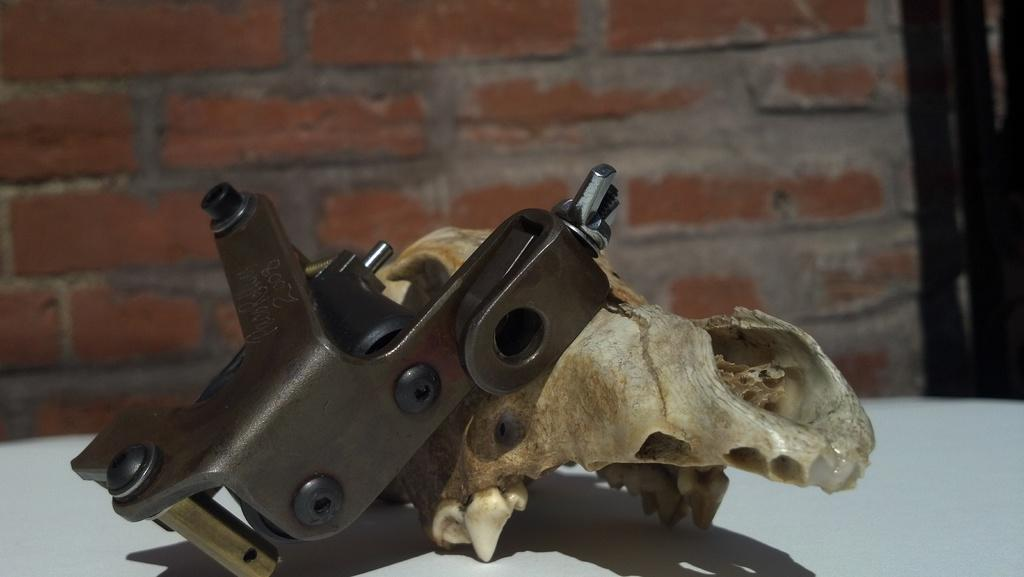What is the main object on the table in the image? There is a skull of an animal on the table. What other object can be seen on the table? There is an iron object on the table. What is visible in the background of the image? There is a wall in the background of the image. What company is responsible for the value of the skull in the image? There is no indication of a company or value associated with the skull in the image. 